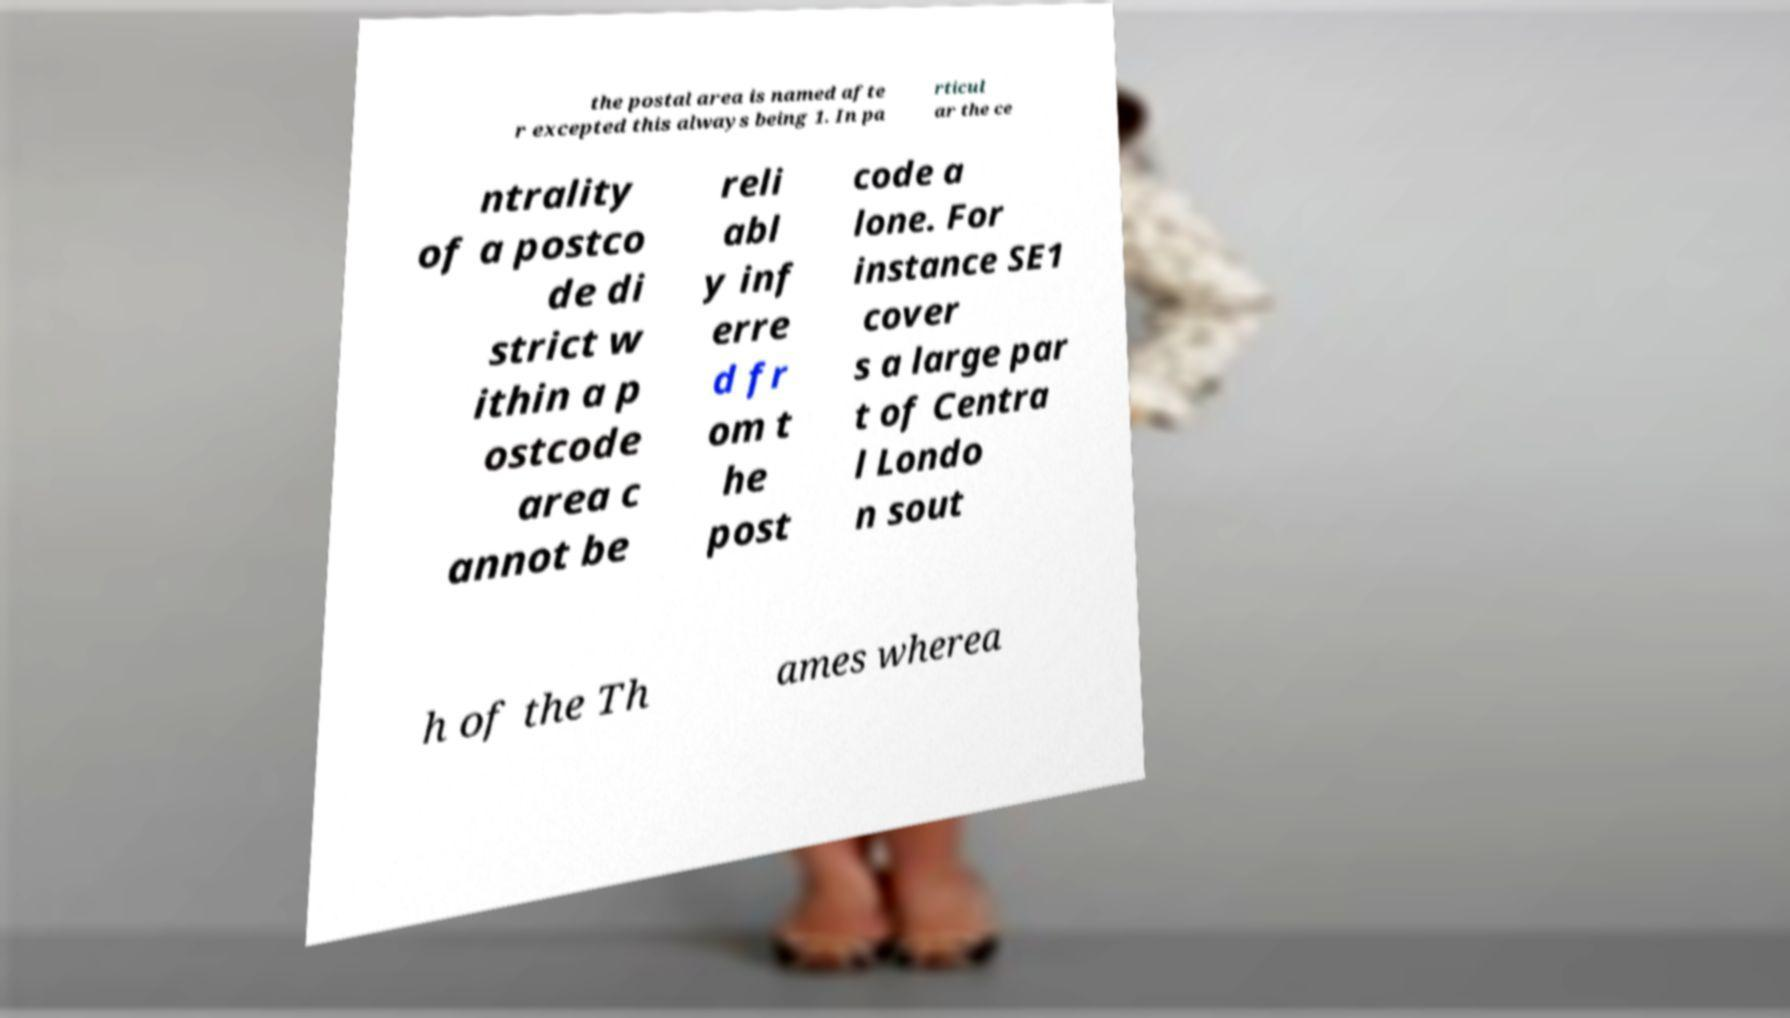What messages or text are displayed in this image? I need them in a readable, typed format. the postal area is named afte r excepted this always being 1. In pa rticul ar the ce ntrality of a postco de di strict w ithin a p ostcode area c annot be reli abl y inf erre d fr om t he post code a lone. For instance SE1 cover s a large par t of Centra l Londo n sout h of the Th ames wherea 